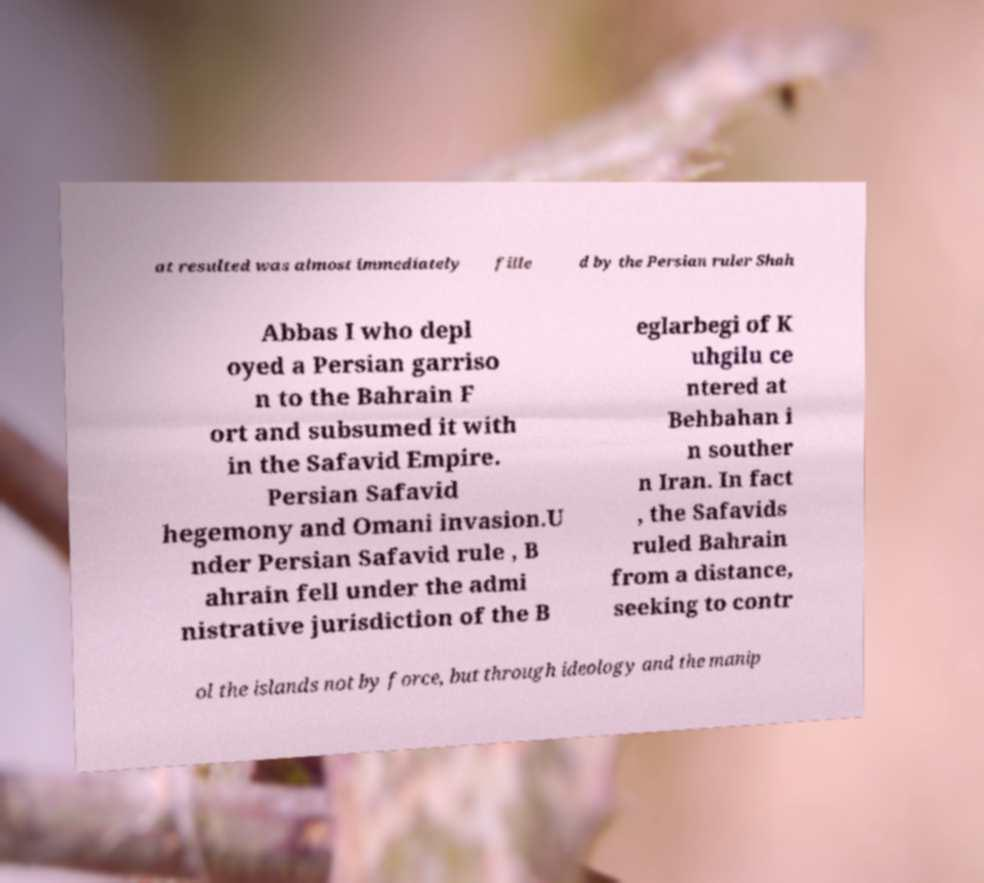Could you extract and type out the text from this image? at resulted was almost immediately fille d by the Persian ruler Shah Abbas I who depl oyed a Persian garriso n to the Bahrain F ort and subsumed it with in the Safavid Empire. Persian Safavid hegemony and Omani invasion.U nder Persian Safavid rule , B ahrain fell under the admi nistrative jurisdiction of the B eglarbegi of K uhgilu ce ntered at Behbahan i n souther n Iran. In fact , the Safavids ruled Bahrain from a distance, seeking to contr ol the islands not by force, but through ideology and the manip 